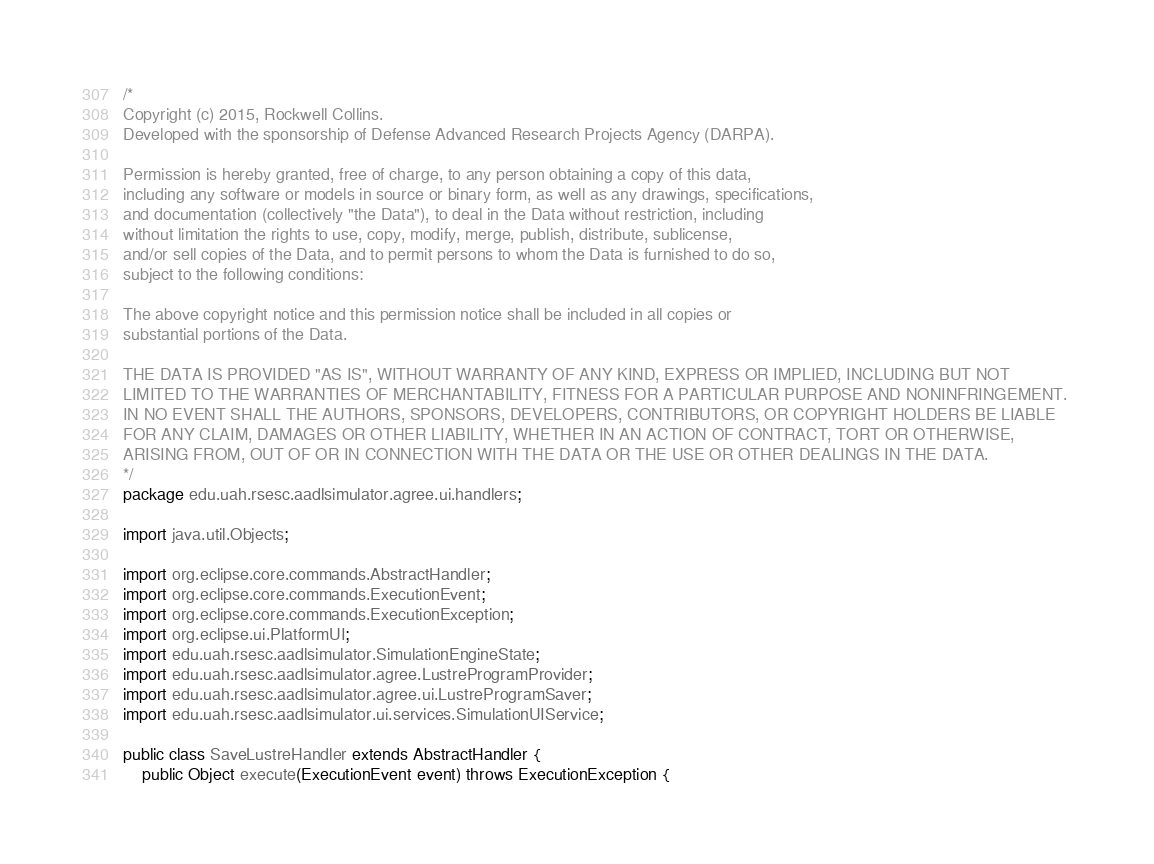<code> <loc_0><loc_0><loc_500><loc_500><_Java_>/*
Copyright (c) 2015, Rockwell Collins.
Developed with the sponsorship of Defense Advanced Research Projects Agency (DARPA).

Permission is hereby granted, free of charge, to any person obtaining a copy of this data, 
including any software or models in source or binary form, as well as any drawings, specifications, 
and documentation (collectively "the Data"), to deal in the Data without restriction, including
without limitation the rights to use, copy, modify, merge, publish, distribute, sublicense, 
and/or sell copies of the Data, and to permit persons to whom the Data is furnished to do so, 
subject to the following conditions:

The above copyright notice and this permission notice shall be included in all copies or 
substantial portions of the Data.

THE DATA IS PROVIDED "AS IS", WITHOUT WARRANTY OF ANY KIND, EXPRESS OR IMPLIED, INCLUDING BUT NOT 
LIMITED TO THE WARRANTIES OF MERCHANTABILITY, FITNESS FOR A PARTICULAR PURPOSE AND NONINFRINGEMENT. 
IN NO EVENT SHALL THE AUTHORS, SPONSORS, DEVELOPERS, CONTRIBUTORS, OR COPYRIGHT HOLDERS BE LIABLE 
FOR ANY CLAIM, DAMAGES OR OTHER LIABILITY, WHETHER IN AN ACTION OF CONTRACT, TORT OR OTHERWISE, 
ARISING FROM, OUT OF OR IN CONNECTION WITH THE DATA OR THE USE OR OTHER DEALINGS IN THE DATA.
*/
package edu.uah.rsesc.aadlsimulator.agree.ui.handlers;

import java.util.Objects;

import org.eclipse.core.commands.AbstractHandler;
import org.eclipse.core.commands.ExecutionEvent;
import org.eclipse.core.commands.ExecutionException;
import org.eclipse.ui.PlatformUI;
import edu.uah.rsesc.aadlsimulator.SimulationEngineState;
import edu.uah.rsesc.aadlsimulator.agree.LustreProgramProvider;
import edu.uah.rsesc.aadlsimulator.agree.ui.LustreProgramSaver;
import edu.uah.rsesc.aadlsimulator.ui.services.SimulationUIService;

public class SaveLustreHandler extends AbstractHandler {
	public Object execute(ExecutionEvent event) throws ExecutionException {</code> 